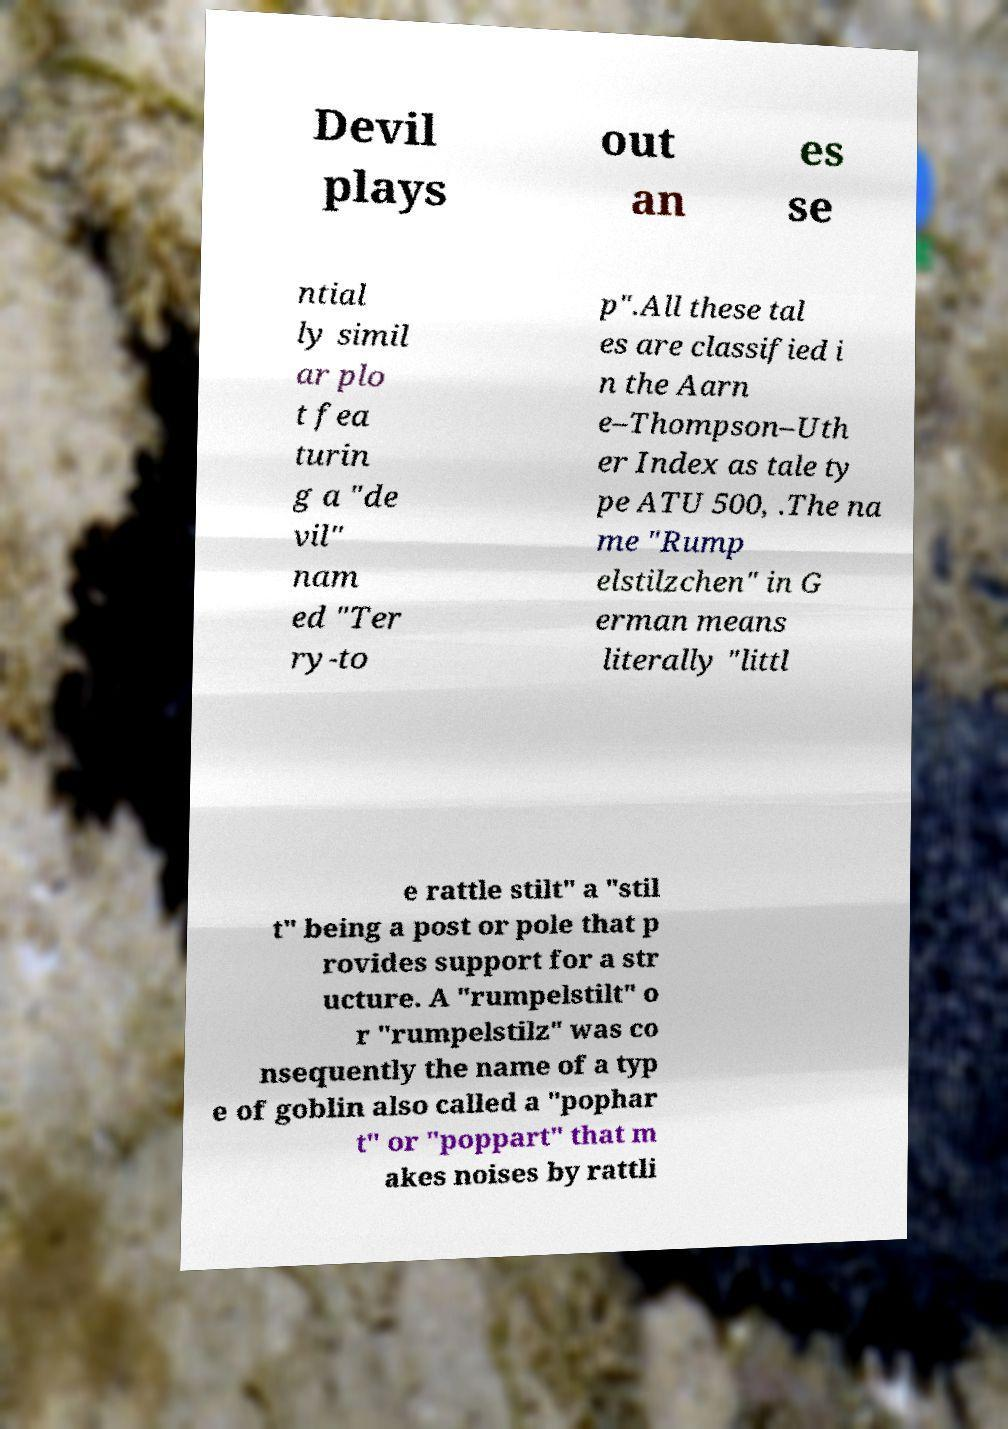Can you read and provide the text displayed in the image?This photo seems to have some interesting text. Can you extract and type it out for me? Devil plays out an es se ntial ly simil ar plo t fea turin g a "de vil" nam ed "Ter ry-to p".All these tal es are classified i n the Aarn e–Thompson–Uth er Index as tale ty pe ATU 500, .The na me "Rump elstilzchen" in G erman means literally "littl e rattle stilt" a "stil t" being a post or pole that p rovides support for a str ucture. A "rumpelstilt" o r "rumpelstilz" was co nsequently the name of a typ e of goblin also called a "pophar t" or "poppart" that m akes noises by rattli 